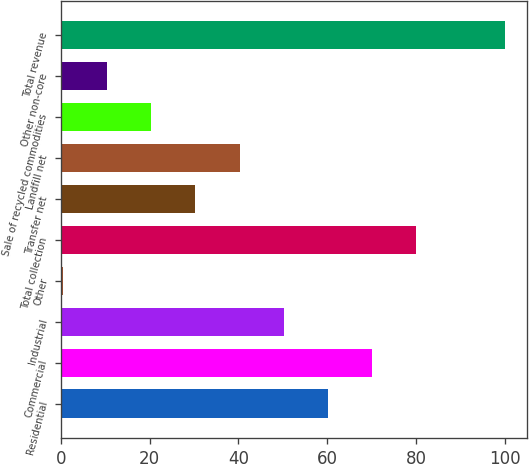Convert chart to OTSL. <chart><loc_0><loc_0><loc_500><loc_500><bar_chart><fcel>Residential<fcel>Commercial<fcel>Industrial<fcel>Other<fcel>Total collection<fcel>Transfer net<fcel>Landfill net<fcel>Sale of recycled commodities<fcel>Other non-core<fcel>Total revenue<nl><fcel>60.16<fcel>70.12<fcel>50.2<fcel>0.4<fcel>80.08<fcel>30.28<fcel>40.24<fcel>20.32<fcel>10.36<fcel>100<nl></chart> 